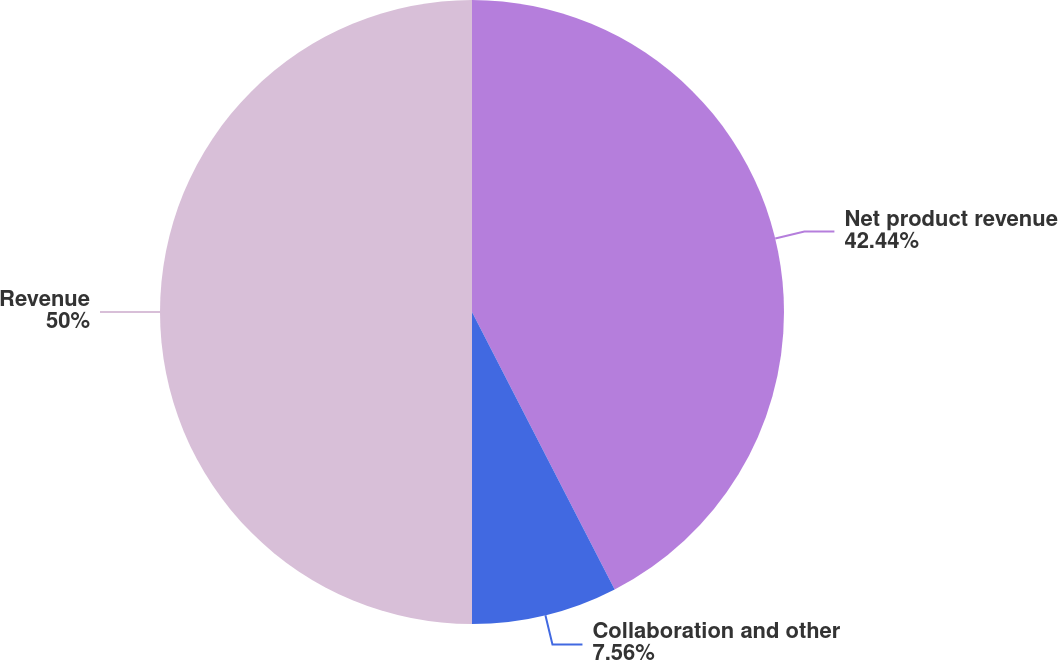<chart> <loc_0><loc_0><loc_500><loc_500><pie_chart><fcel>Net product revenue<fcel>Collaboration and other<fcel>Revenue<nl><fcel>42.44%<fcel>7.56%<fcel>50.0%<nl></chart> 